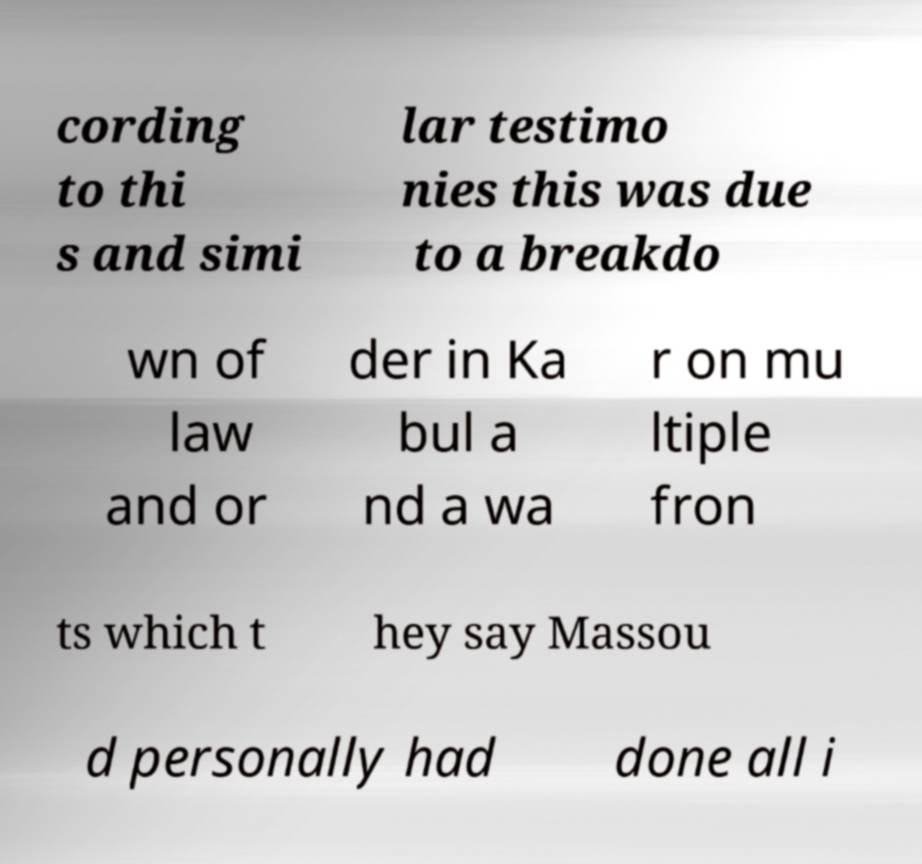Please read and relay the text visible in this image. What does it say? cording to thi s and simi lar testimo nies this was due to a breakdo wn of law and or der in Ka bul a nd a wa r on mu ltiple fron ts which t hey say Massou d personally had done all i 